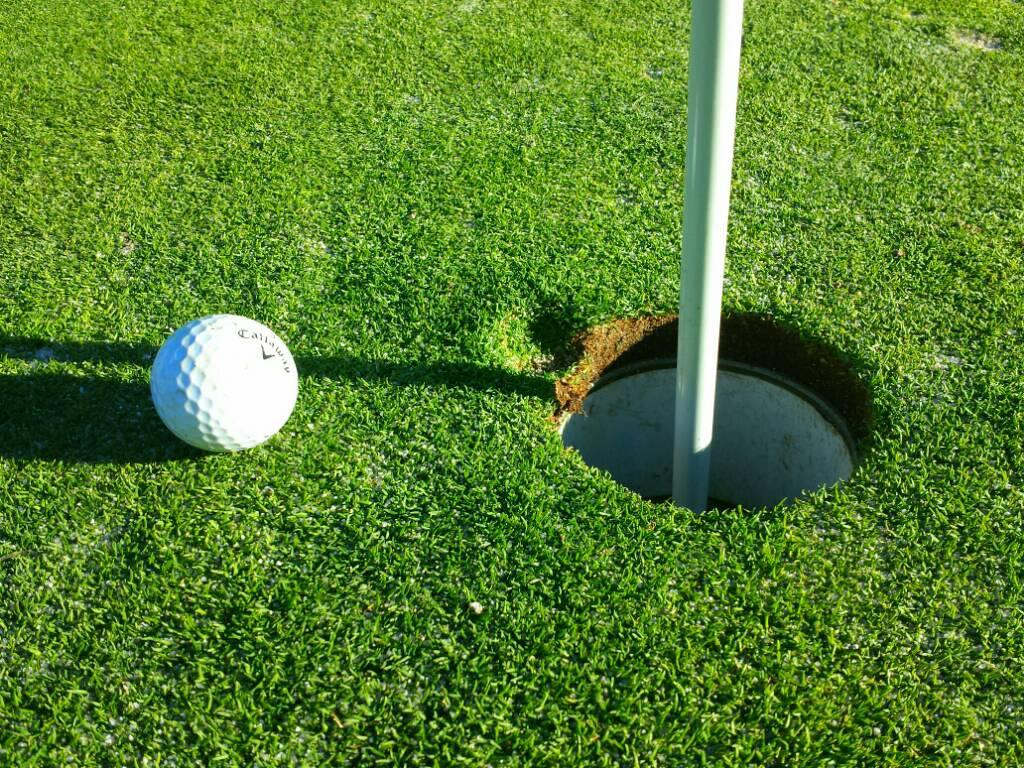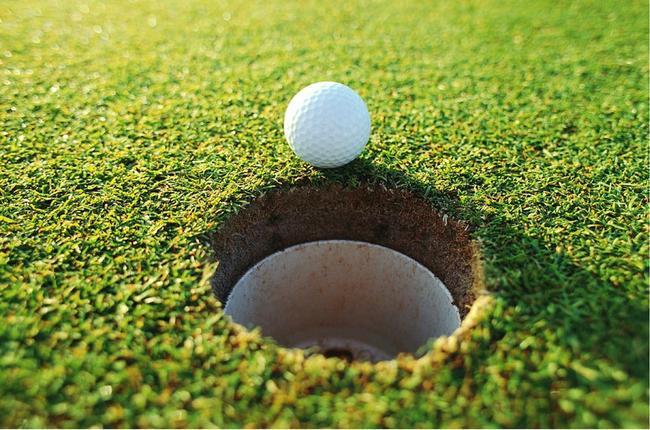The first image is the image on the left, the second image is the image on the right. Examine the images to the left and right. Is the description "single golf balls are perched at the edge of the hole" accurate? Answer yes or no. Yes. The first image is the image on the left, the second image is the image on the right. Evaluate the accuracy of this statement regarding the images: "There is one golf ball resting next to a hole in the image on the right". Is it true? Answer yes or no. Yes. 